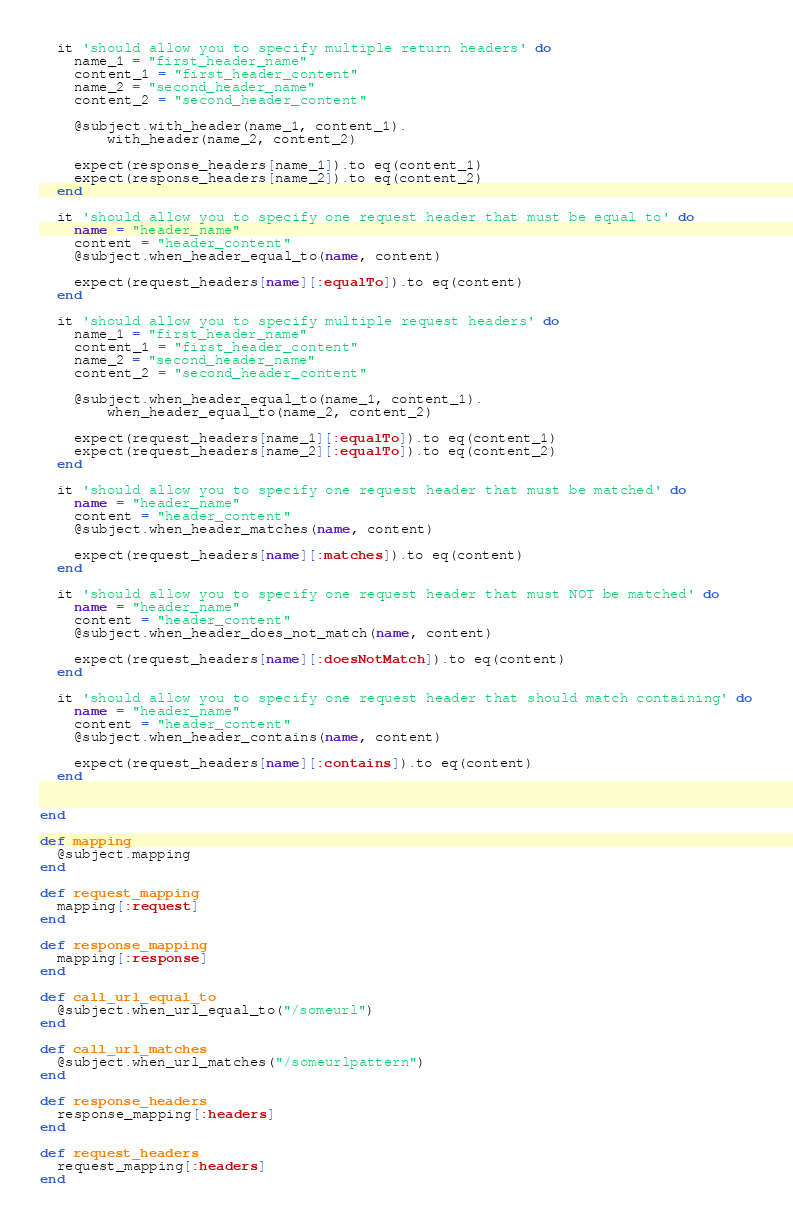<code> <loc_0><loc_0><loc_500><loc_500><_Ruby_>
  it 'should allow you to specify multiple return headers' do
    name_1 = "first_header_name"
    content_1 = "first_header_content"
    name_2 = "second_header_name"
    content_2 = "second_header_content"

    @subject.with_header(name_1, content_1).
        with_header(name_2, content_2)

    expect(response_headers[name_1]).to eq(content_1)
    expect(response_headers[name_2]).to eq(content_2)
  end

  it 'should allow you to specify one request header that must be equal to' do
    name = "header_name"
    content = "header_content"
    @subject.when_header_equal_to(name, content)

    expect(request_headers[name][:equalTo]).to eq(content)
  end

  it 'should allow you to specify multiple request headers' do
    name_1 = "first_header_name"
    content_1 = "first_header_content"
    name_2 = "second_header_name"
    content_2 = "second_header_content"

    @subject.when_header_equal_to(name_1, content_1).
        when_header_equal_to(name_2, content_2)

    expect(request_headers[name_1][:equalTo]).to eq(content_1)
    expect(request_headers[name_2][:equalTo]).to eq(content_2)
  end

  it 'should allow you to specify one request header that must be matched' do
    name = "header_name"
    content = "header_content"
    @subject.when_header_matches(name, content)

    expect(request_headers[name][:matches]).to eq(content)
  end

  it 'should allow you to specify one request header that must NOT be matched' do
    name = "header_name"
    content = "header_content"
    @subject.when_header_does_not_match(name, content)

    expect(request_headers[name][:doesNotMatch]).to eq(content)
  end

  it 'should allow you to specify one request header that should match containing' do
    name = "header_name"
    content = "header_content"
    @subject.when_header_contains(name, content)

    expect(request_headers[name][:contains]).to eq(content)
  end


end

def mapping
  @subject.mapping
end

def request_mapping
  mapping[:request]
end

def response_mapping
  mapping[:response]
end

def call_url_equal_to
  @subject.when_url_equal_to("/someurl")
end

def call_url_matches
  @subject.when_url_matches("/someurlpattern")
end

def response_headers
  response_mapping[:headers]
end

def request_headers
  request_mapping[:headers]
end

</code> 